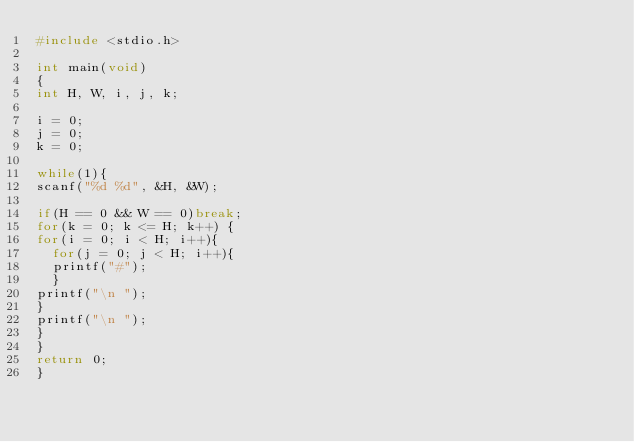<code> <loc_0><loc_0><loc_500><loc_500><_C_>#include <stdio.h>

int main(void)
{
int H, W, i, j, k;

i = 0;
j = 0;
k = 0;

while(1){
scanf("%d %d", &H, &W);

if(H == 0 && W == 0)break;
for(k = 0; k <= H; k++) {
for(i = 0; i < H; i++){
  for(j = 0; j < H; i++){
  printf("#");
  }
printf("\n ");
}
printf("\n ");
}
}
return 0;
}
</code> 